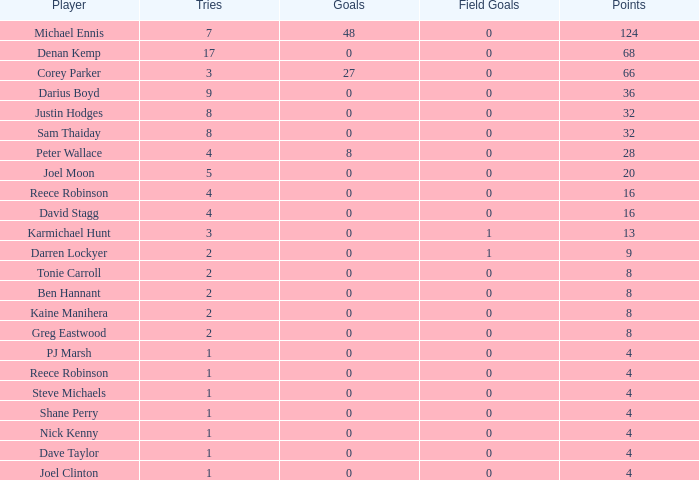Parse the table in full. {'header': ['Player', 'Tries', 'Goals', 'Field Goals', 'Points'], 'rows': [['Michael Ennis', '7', '48', '0', '124'], ['Denan Kemp', '17', '0', '0', '68'], ['Corey Parker', '3', '27', '0', '66'], ['Darius Boyd', '9', '0', '0', '36'], ['Justin Hodges', '8', '0', '0', '32'], ['Sam Thaiday', '8', '0', '0', '32'], ['Peter Wallace', '4', '8', '0', '28'], ['Joel Moon', '5', '0', '0', '20'], ['Reece Robinson', '4', '0', '0', '16'], ['David Stagg', '4', '0', '0', '16'], ['Karmichael Hunt', '3', '0', '1', '13'], ['Darren Lockyer', '2', '0', '1', '9'], ['Tonie Carroll', '2', '0', '0', '8'], ['Ben Hannant', '2', '0', '0', '8'], ['Kaine Manihera', '2', '0', '0', '8'], ['Greg Eastwood', '2', '0', '0', '8'], ['PJ Marsh', '1', '0', '0', '4'], ['Reece Robinson', '1', '0', '0', '4'], ['Steve Michaels', '1', '0', '0', '4'], ['Shane Perry', '1', '0', '0', '4'], ['Nick Kenny', '1', '0', '0', '4'], ['Dave Taylor', '1', '0', '0', '4'], ['Joel Clinton', '1', '0', '0', '4']]} What is the quantity of goals dave taylor, who has over 1 tries, possesses? None. 